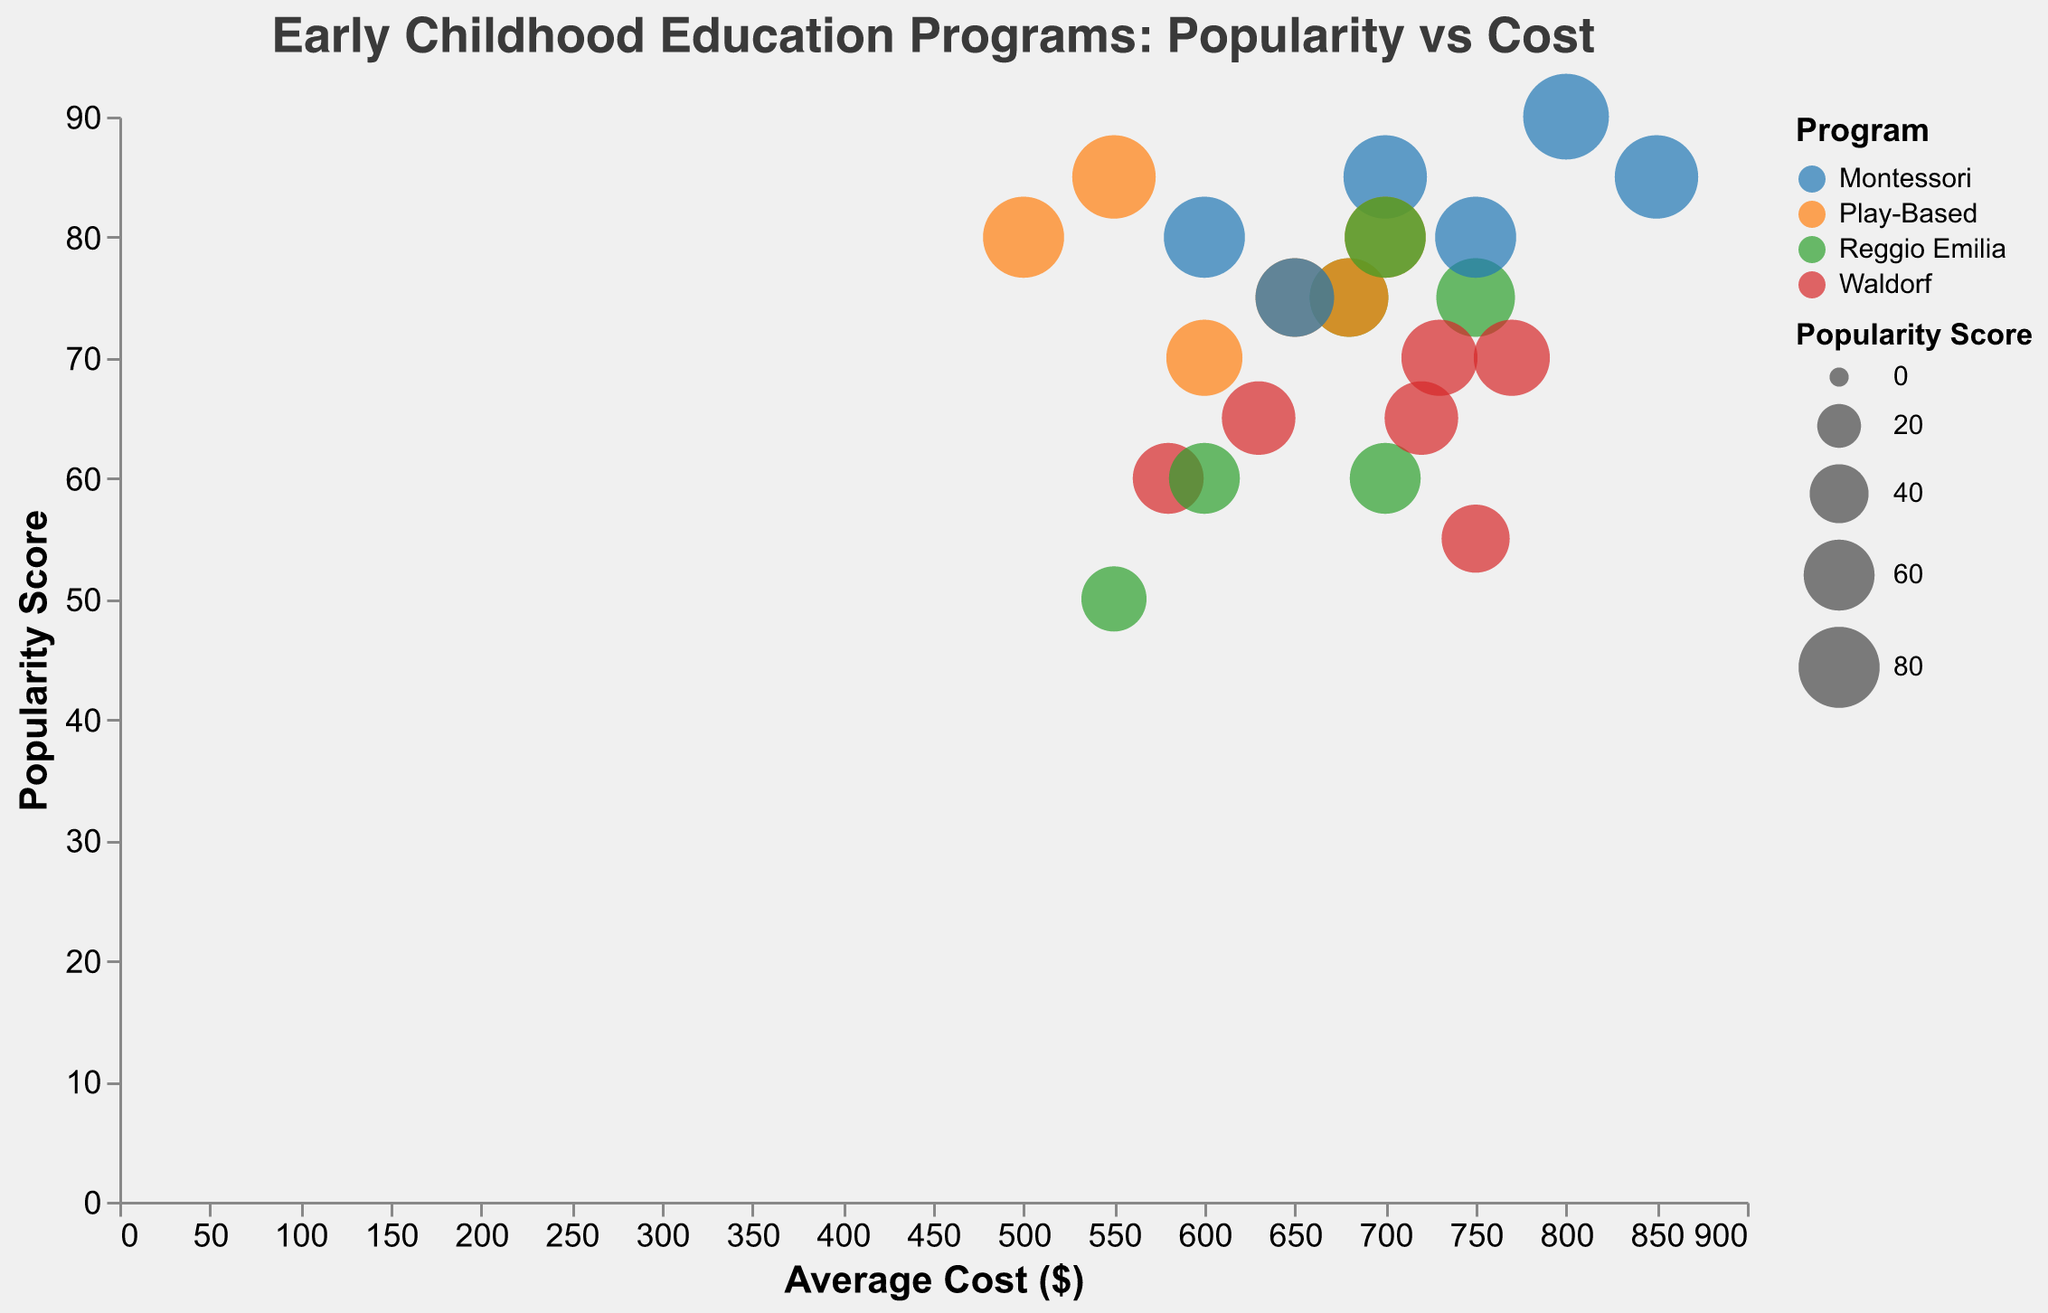What's the title of the figure? The title is located at the top of the figure, which reads "Early Childhood Education Programs: Popularity vs Cost".
Answer: Early Childhood Education Programs: Popularity vs Cost Which program has the highest popularity score among the 3-4 age group in North America? Look for the 3-4 age group in North America and identify the bubble with the highest Popularity Score. It is the Montessori program with a score of 90.
Answer: Montessori What is the average cost of the Play-Based program in Asia for both age groups combined? First, find the Average Cost for the Play-Based program in Asia for each age group: $500 for age 3-4 and $550 for age 4-5. Calculate the average of these two values: (500 + 550) / 2 = 525.
Answer: 525 Which program shows the highest increase in popularity score when moving from the age group 3-4 to 4-5 in Europe? Compare the popularity scores of each program in Europe for the age groups 3-4 and 4-5. Determine the difference for each program and identify the one with the highest increase. Montessori decreases by 5, Play-Based increases by 5, Reggio Emilia increases by 5, and Waldorf stays the same. So there is no "highest" since three programs show the same increase.
Answer: Play-Based, Reggio Emilia Between the Montessori program in North America and the Play-Based program in Asia, which has a higher popularity score for the age group 4-5? Compare the popularity score for Montessori in North America and Play-Based in Asia for the age group 4-5. Montessori in North America has a popularity score of 85, while Play-Based in Asia has a score of 85.
Answer: Equal What is the difference in average cost between the Reggio Emilia program and the Waldorf program in Europe for the age group 3-4? Find the Average Cost for Reggio Emilia ($680) and Waldorf ($720) in Europe for age group 3-4. Calculate the difference: 720 - 680 = 40.
Answer: 40 Which region has the highest popularity score for the Waldorf program for age group 3-4? Check the popularity scores for the Waldorf program for the age group 3-4 in all regions. North America has 55, Europe has 65, and Asia has 60. The highest is in Europe with a score of 65.
Answer: Europe What is the median popularity score for Play-Based programs across all regions for the age group 4-5? List the popularity scores for Play-Based programs in all regions for the age group 4-5: 80 (North America), 75 (Europe), and 85 (Asia). Arrange them in order: 75, 80, 85. The median value (middle score) is 80.
Answer: 80 